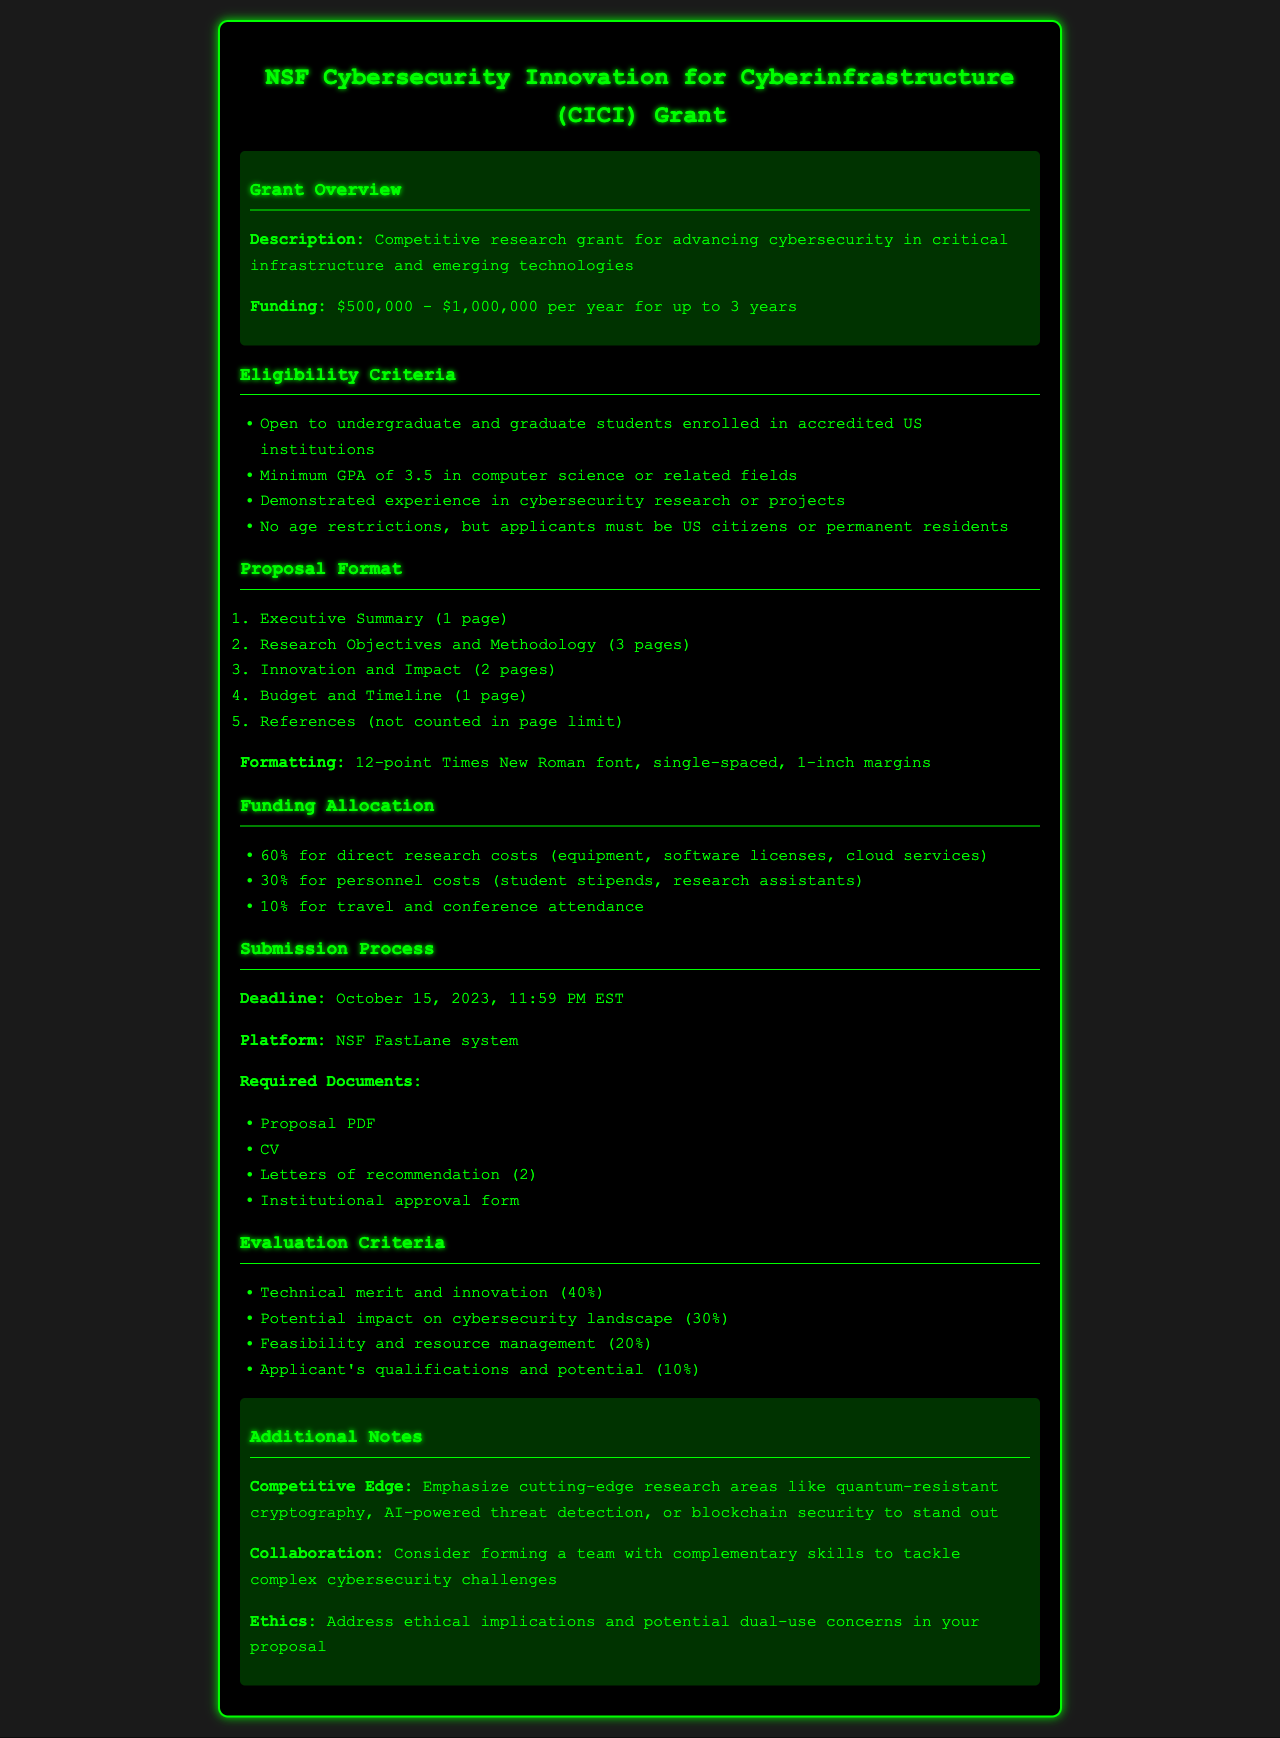What is the funding range for the grant? The document states that the funding is between $500,000 and $1,000,000 per year for up to 3 years.
Answer: $500,000 - $1,000,000 What is the minimum GPA requirement? The eligibility criteria specify a minimum GPA of 3.5 in computer science or related fields.
Answer: 3.5 How many pages is the Executive Summary limited to? The proposal format section indicates that the Executive Summary should be one page long.
Answer: 1 page What percentage of the budget is allocated for direct research costs? The funding allocation indicates that 60% of the budget is for direct research costs.
Answer: 60% What is the submission deadline? The document specifies that the deadline for submission is October 15, 2023, at 11:59 PM EST.
Answer: October 15, 2023 What is the percentage weight for technical merit and innovation in the evaluation criteria? The evaluation criteria section states that technical merit and innovation account for 40% of the evaluation.
Answer: 40% What types of documents are required for submission? The required documents include Proposal PDF, CV, Letters of recommendation (2), and Institutional approval form.
Answer: Proposal PDF, CV, Letters of recommendation (2), Institutional approval form What aspect should be emphasized for a competitive edge? The document notes that applicants should emphasize cutting-edge research areas like quantum-resistant cryptography.
Answer: Cutting-edge research areas like quantum-resistant cryptography What platform must be used for submission? The submission process specifies that the NSF FastLane system must be used for submission.
Answer: NSF FastLane system 